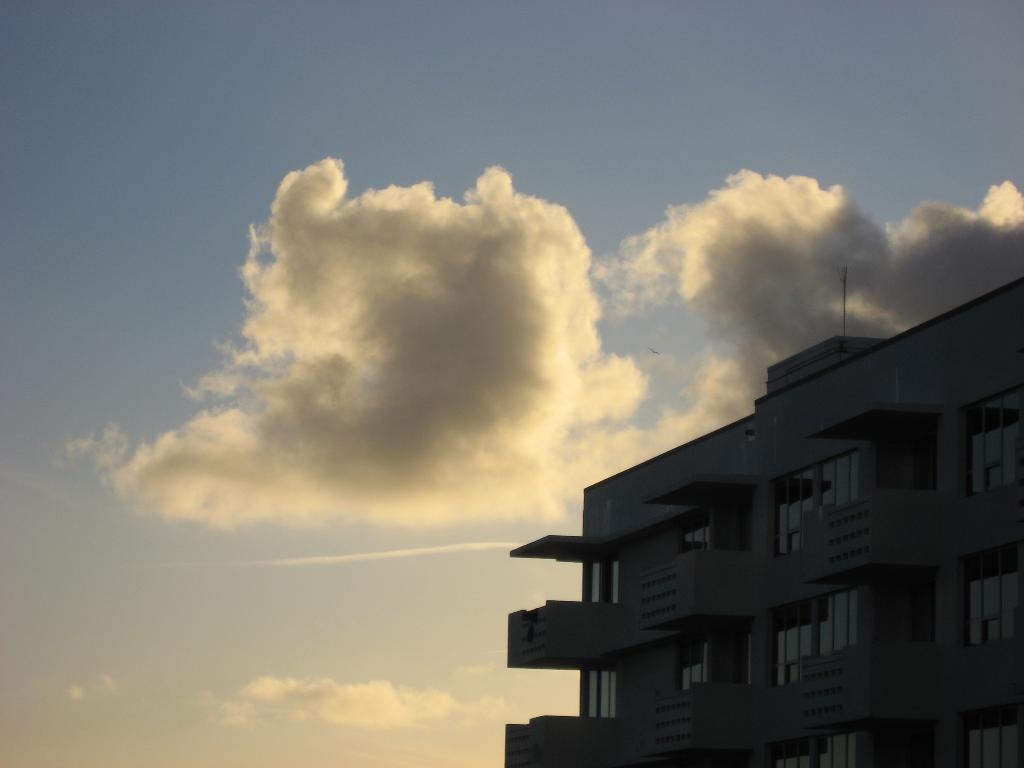What structure is located on the right side of the image? There is a building on the right side of the image. What is visible in the background of the image? The sky is visible in the image. What can be seen in the sky? Clouds are present in the sky. How many crates are stacked on the donkey in the image? There are no crates or donkeys present in the image. 